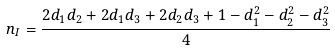Convert formula to latex. <formula><loc_0><loc_0><loc_500><loc_500>n _ { I } = \frac { 2 d _ { 1 } d _ { 2 } + 2 d _ { 1 } d _ { 3 } + 2 d _ { 2 } d _ { 3 } + 1 - d _ { 1 } ^ { 2 } - d _ { 2 } ^ { 2 } - d _ { 3 } ^ { 2 } } { 4 }</formula> 